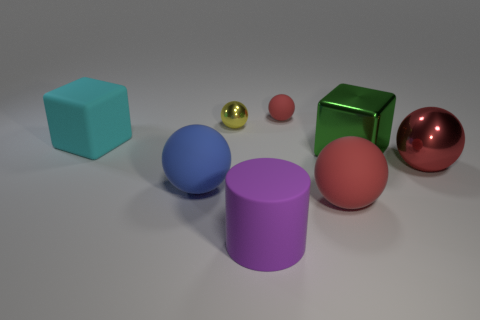Are there any objects here that can reflect light well? Yes, the two spheres, one gold and one red, exhibit reflective properties, which suggests they are likely made from a metallic material that can reflect light effectively. 